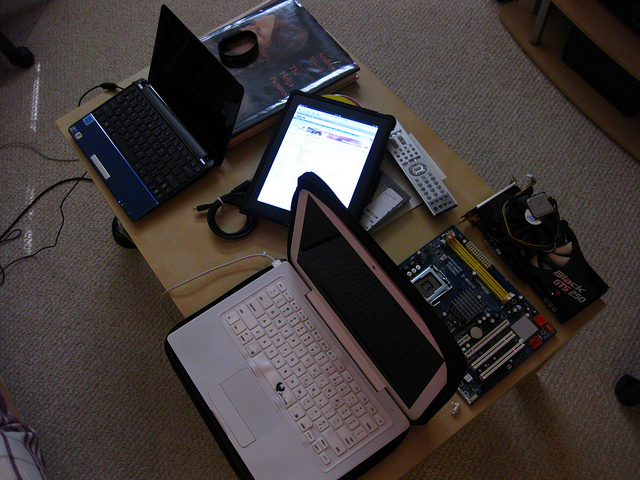Please transcribe the text in this image. GTS 